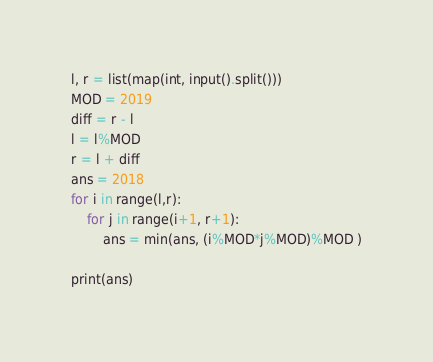Convert code to text. <code><loc_0><loc_0><loc_500><loc_500><_Python_>l, r = list(map(int, input().split()))
MOD = 2019
diff = r - l
l = l%MOD
r = l + diff
ans = 2018
for i in range(l,r):
    for j in range(i+1, r+1):
        ans = min(ans, (i%MOD*j%MOD)%MOD )
      
print(ans)</code> 